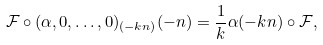Convert formula to latex. <formula><loc_0><loc_0><loc_500><loc_500>\mathcal { F } \circ ( \alpha , 0 , \dots , 0 ) _ { ( - k n ) } ( - n ) = \frac { 1 } { k } \alpha ( - k n ) \circ \mathcal { F } ,</formula> 